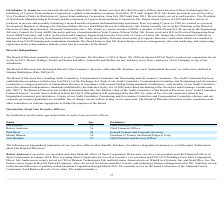According to Xperi Corporation's financial document, Who is the Chief Financial Officer? According to the financial document, Robert Andersen. The relevant text states: "Robert Andersen 56 Chief Financial Officer..." Also, When did Paul Davis join Xperi Corporation? Based on the financial document, the answer is August 2011. Also, What degrees does Geir Skaaden hold? Based on the financial document, the answer is a B.A. in Finance from the University of Oregon, a Business degree from the Norwegian School of Management and an M.B.A. from the University of Washington. Also, can you calculate: What is the average age of the executive officers of Xperi Corporation? To answer this question, I need to perform calculations using the financial data. The calculation is: (52+56+44+58+53)/5 , which equals 52.6. This is based on the information: "Robert Andersen 56 Chief Financial Officer Murali Dharan 58 President of Tessera Intellectual Property Corp. Geir Skaaden 53 Chief Products and Services Officer Jon Kirchner 52 Chief Executive Officer..." The key data points involved are: 44, 53, 56. Also, can you calculate: What is the percentage of years that Geir Skaaden served as the Chief Executive Officer of Neural Audio Corporation throughout his life? To answer this question, I need to perform calculations using the financial data. The calculation is: (2008-2004)/53 , which equals 7.55 (percentage). This is based on the information: "Geir Skaaden 53 Chief Products and Services Officer..." The key data points involved are: 2004, 2008, 53. Additionally, Who is the oldest among all executive officers of Xperi Corporation? According to the financial document, Murali Dharan. The relevant text states: "Murali Dharan 58 President of Tessera Intellectual Property Corp...." 